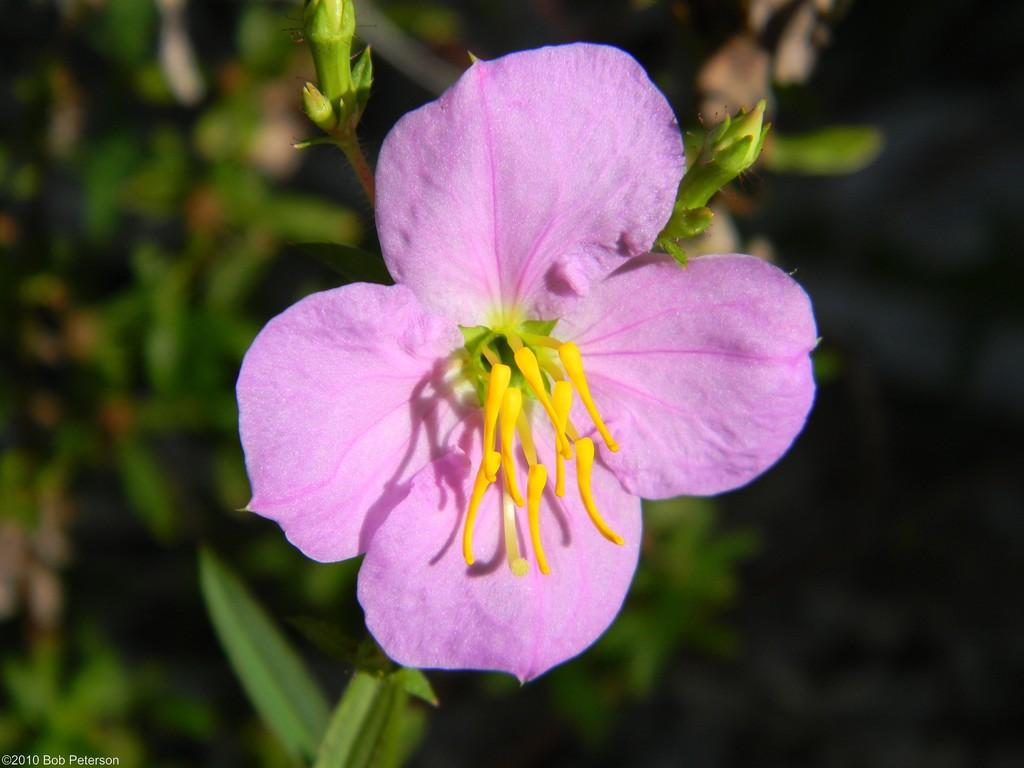What is the main subject of the image? There is a flower in the image. What can be observed about the flower's growth stage? There are buds on the stem of the plant in the image. What else can be seen in the image besides the flower? There are plants visible in the background of the image. What is written or displayed at the bottom of the image? There is text at the bottom of the image. How many slaves are visible in the image? There are no slaves present in the image. What type of bean is growing on the plant in the image? The image does not depict a bean plant; it features a flowering plant. 